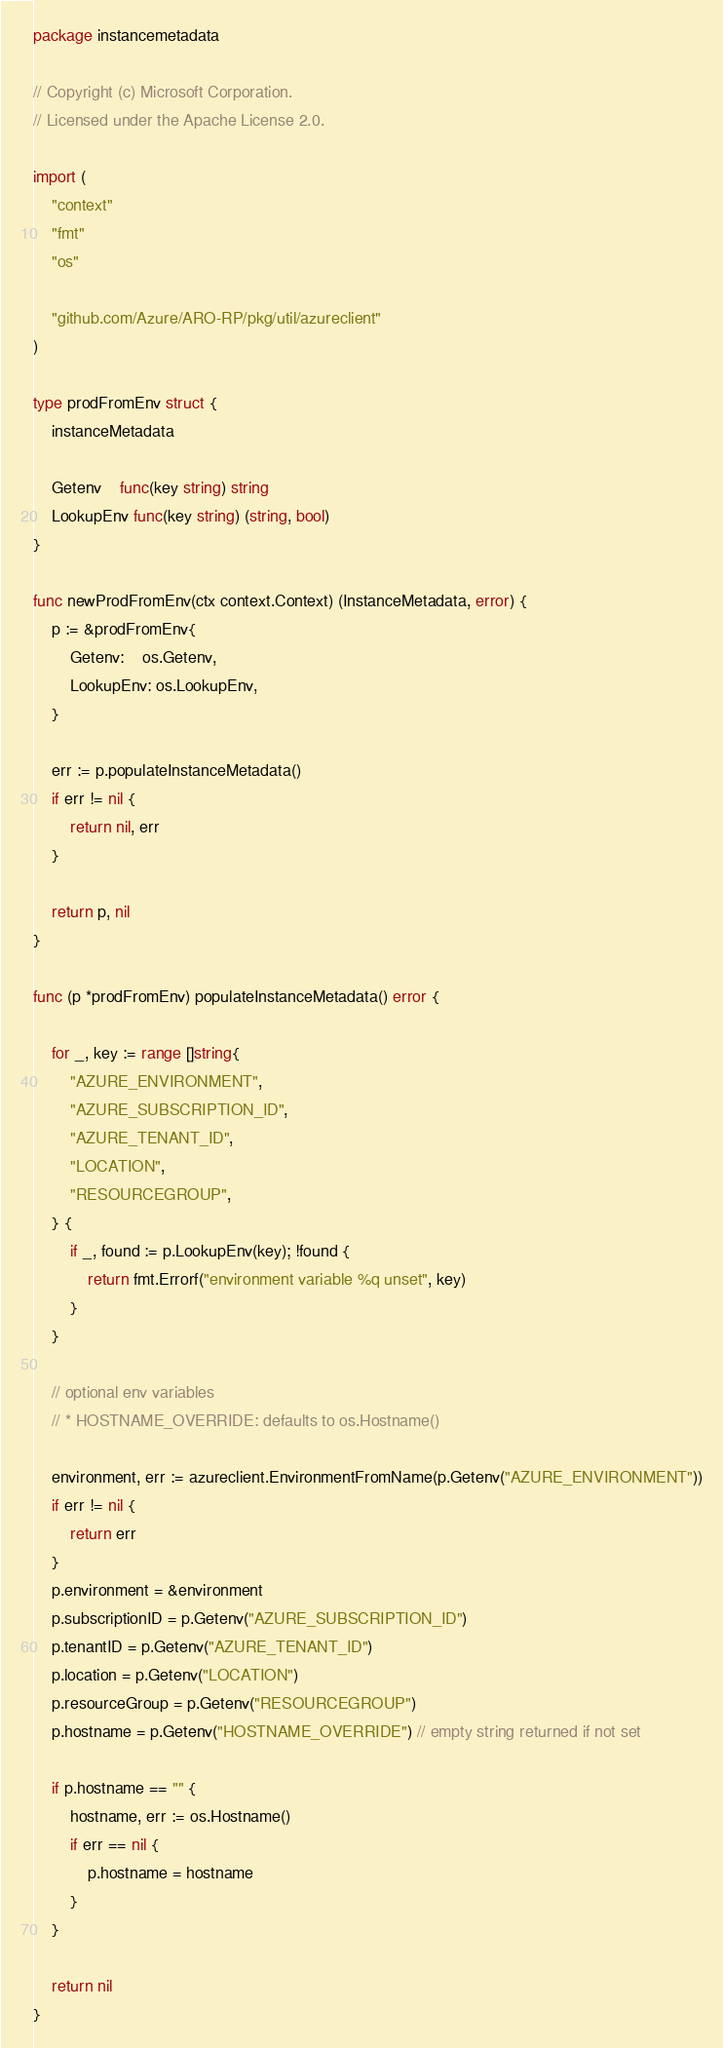<code> <loc_0><loc_0><loc_500><loc_500><_Go_>package instancemetadata

// Copyright (c) Microsoft Corporation.
// Licensed under the Apache License 2.0.

import (
	"context"
	"fmt"
	"os"

	"github.com/Azure/ARO-RP/pkg/util/azureclient"
)

type prodFromEnv struct {
	instanceMetadata

	Getenv    func(key string) string
	LookupEnv func(key string) (string, bool)
}

func newProdFromEnv(ctx context.Context) (InstanceMetadata, error) {
	p := &prodFromEnv{
		Getenv:    os.Getenv,
		LookupEnv: os.LookupEnv,
	}

	err := p.populateInstanceMetadata()
	if err != nil {
		return nil, err
	}

	return p, nil
}

func (p *prodFromEnv) populateInstanceMetadata() error {

	for _, key := range []string{
		"AZURE_ENVIRONMENT",
		"AZURE_SUBSCRIPTION_ID",
		"AZURE_TENANT_ID",
		"LOCATION",
		"RESOURCEGROUP",
	} {
		if _, found := p.LookupEnv(key); !found {
			return fmt.Errorf("environment variable %q unset", key)
		}
	}

	// optional env variables
	// * HOSTNAME_OVERRIDE: defaults to os.Hostname()

	environment, err := azureclient.EnvironmentFromName(p.Getenv("AZURE_ENVIRONMENT"))
	if err != nil {
		return err
	}
	p.environment = &environment
	p.subscriptionID = p.Getenv("AZURE_SUBSCRIPTION_ID")
	p.tenantID = p.Getenv("AZURE_TENANT_ID")
	p.location = p.Getenv("LOCATION")
	p.resourceGroup = p.Getenv("RESOURCEGROUP")
	p.hostname = p.Getenv("HOSTNAME_OVERRIDE") // empty string returned if not set

	if p.hostname == "" {
		hostname, err := os.Hostname()
		if err == nil {
			p.hostname = hostname
		}
	}

	return nil
}
</code> 